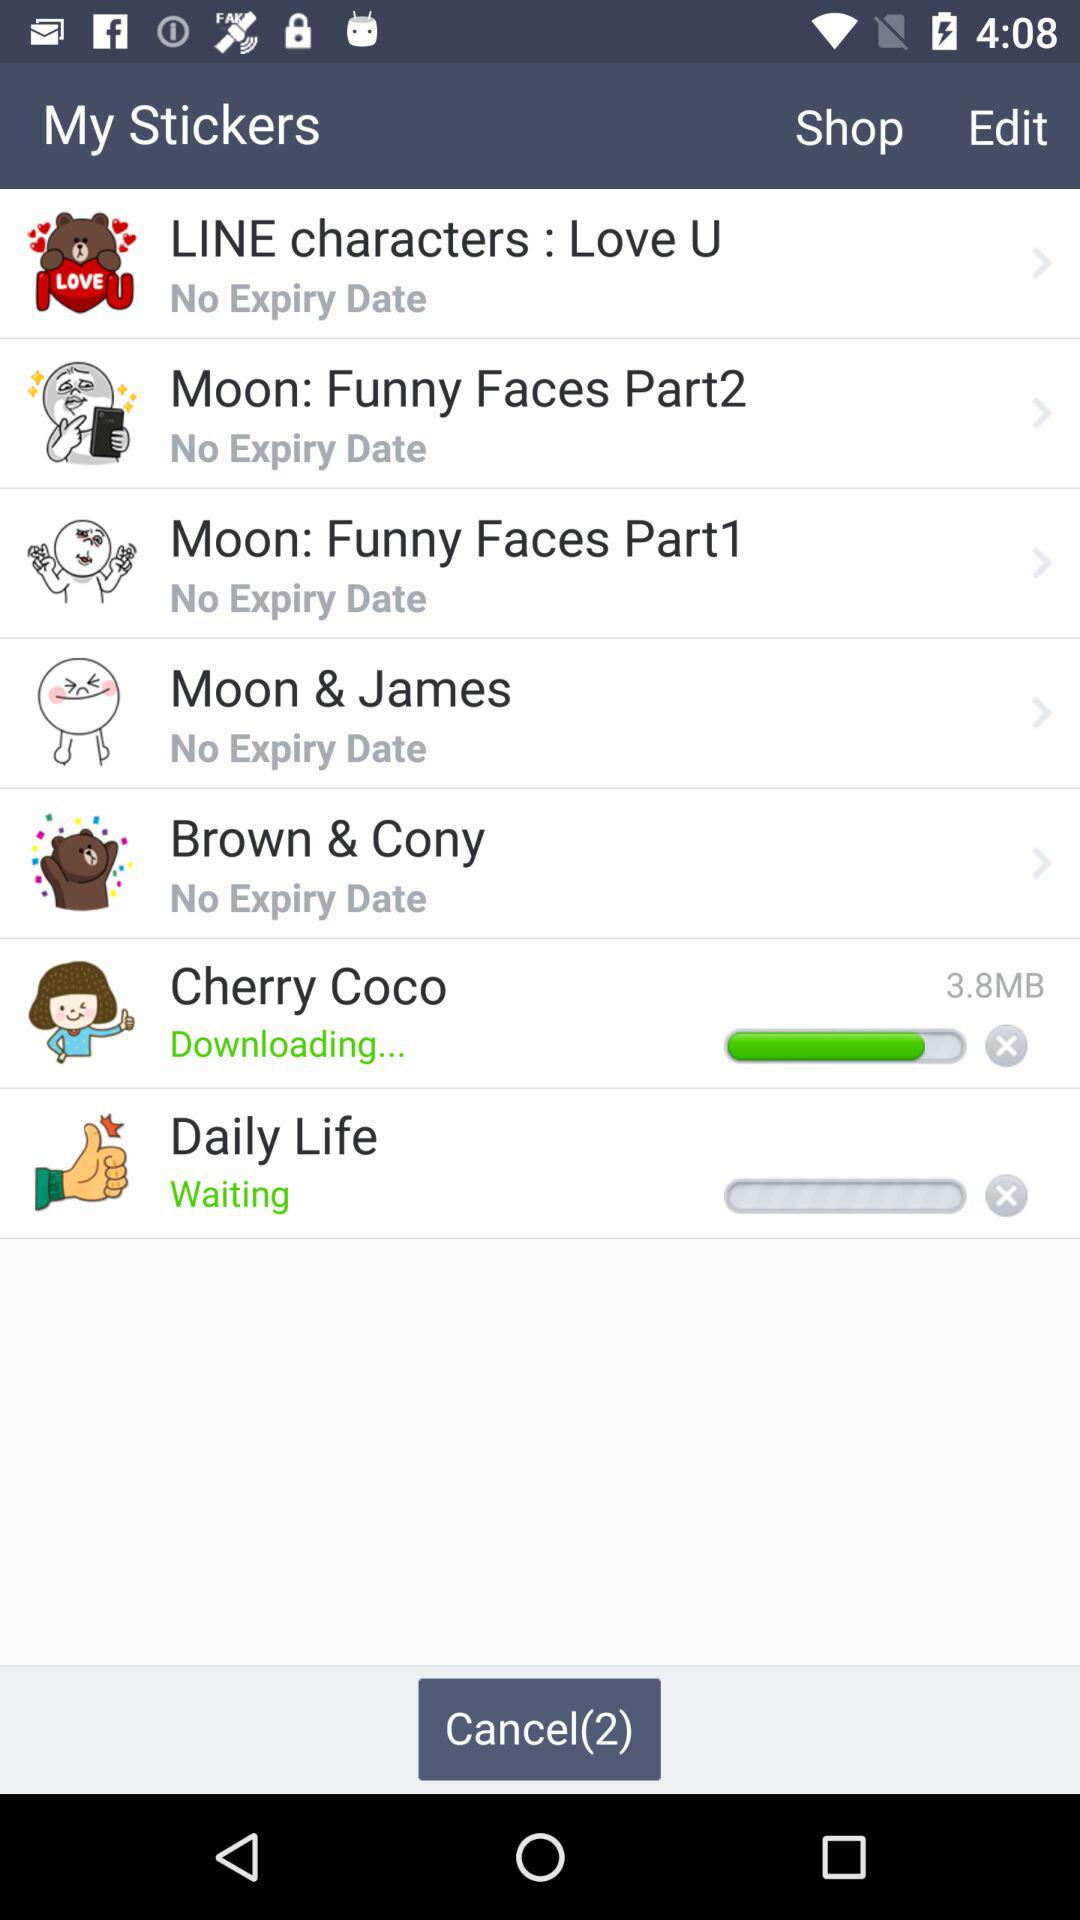How much of the "Cherry Coco" sticker file has been downloaded? The "Cherry Coco" sticker file has been downloaded to 3.8 MB. 